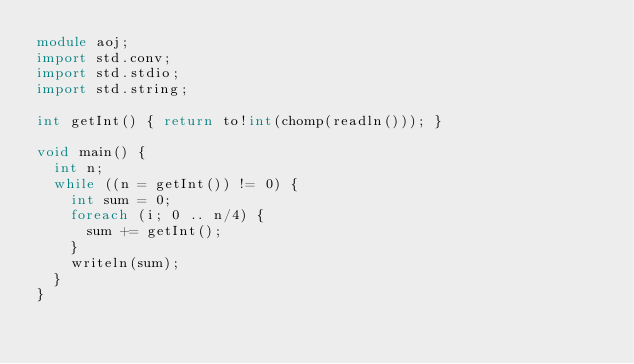<code> <loc_0><loc_0><loc_500><loc_500><_D_>module aoj;
import std.conv;
import std.stdio;
import std.string;

int getInt() { return to!int(chomp(readln())); }

void main() {
  int n;
  while ((n = getInt()) != 0) {
    int sum = 0;
    foreach (i; 0 .. n/4) {
      sum += getInt();
    }
    writeln(sum);
  }
}</code> 